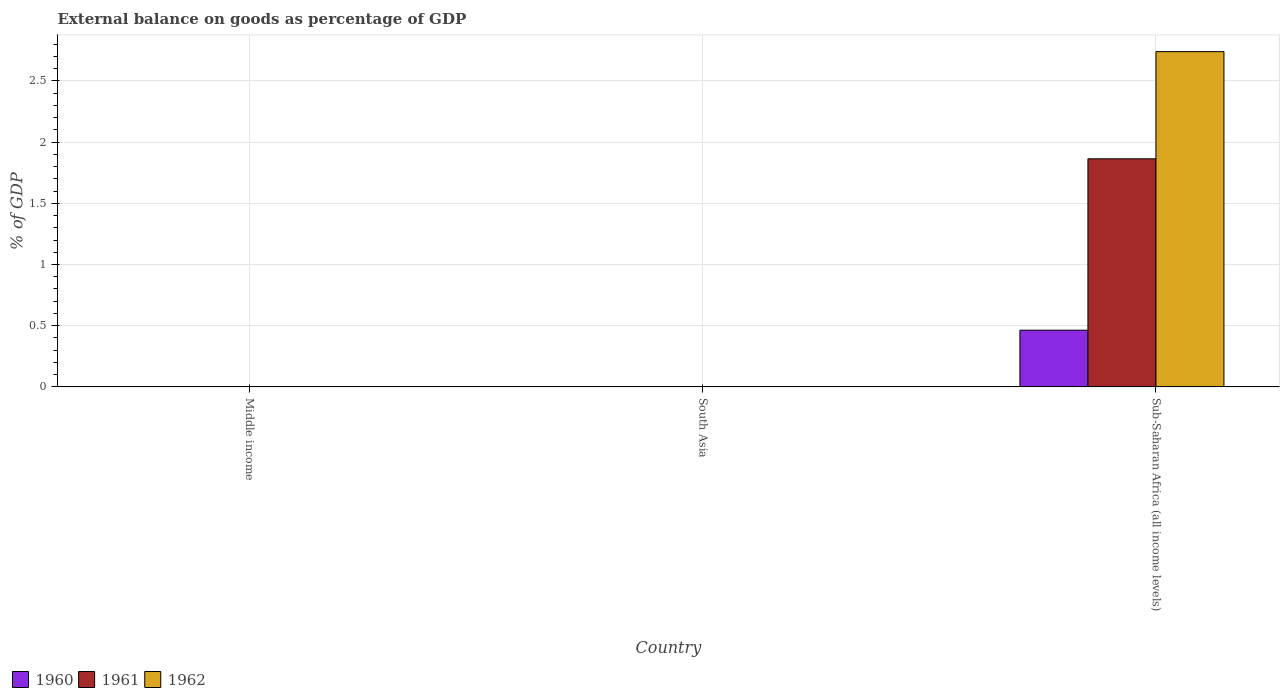How many different coloured bars are there?
Make the answer very short. 3. Are the number of bars per tick equal to the number of legend labels?
Make the answer very short. No. How many bars are there on the 1st tick from the left?
Your response must be concise. 0. How many bars are there on the 3rd tick from the right?
Make the answer very short. 0. In how many cases, is the number of bars for a given country not equal to the number of legend labels?
Keep it short and to the point. 2. What is the external balance on goods as percentage of GDP in 1962 in Sub-Saharan Africa (all income levels)?
Your answer should be very brief. 2.74. Across all countries, what is the maximum external balance on goods as percentage of GDP in 1961?
Offer a terse response. 1.86. Across all countries, what is the minimum external balance on goods as percentage of GDP in 1961?
Offer a very short reply. 0. In which country was the external balance on goods as percentage of GDP in 1961 maximum?
Keep it short and to the point. Sub-Saharan Africa (all income levels). What is the total external balance on goods as percentage of GDP in 1962 in the graph?
Give a very brief answer. 2.74. What is the difference between the external balance on goods as percentage of GDP in 1962 in Middle income and the external balance on goods as percentage of GDP in 1961 in Sub-Saharan Africa (all income levels)?
Ensure brevity in your answer.  -1.86. What is the average external balance on goods as percentage of GDP in 1962 per country?
Keep it short and to the point. 0.91. What is the difference between the external balance on goods as percentage of GDP of/in 1962 and external balance on goods as percentage of GDP of/in 1961 in Sub-Saharan Africa (all income levels)?
Your answer should be very brief. 0.88. In how many countries, is the external balance on goods as percentage of GDP in 1962 greater than 0.2 %?
Offer a terse response. 1. What is the difference between the highest and the lowest external balance on goods as percentage of GDP in 1961?
Offer a very short reply. 1.86. How many bars are there?
Your answer should be compact. 3. How many countries are there in the graph?
Keep it short and to the point. 3. Are the values on the major ticks of Y-axis written in scientific E-notation?
Your answer should be very brief. No. Does the graph contain any zero values?
Give a very brief answer. Yes. Does the graph contain grids?
Provide a succinct answer. Yes. How are the legend labels stacked?
Provide a short and direct response. Horizontal. What is the title of the graph?
Provide a short and direct response. External balance on goods as percentage of GDP. Does "2002" appear as one of the legend labels in the graph?
Your response must be concise. No. What is the label or title of the Y-axis?
Provide a succinct answer. % of GDP. What is the % of GDP of 1962 in Middle income?
Offer a terse response. 0. What is the % of GDP in 1961 in South Asia?
Provide a short and direct response. 0. What is the % of GDP of 1960 in Sub-Saharan Africa (all income levels)?
Give a very brief answer. 0.46. What is the % of GDP of 1961 in Sub-Saharan Africa (all income levels)?
Offer a very short reply. 1.86. What is the % of GDP in 1962 in Sub-Saharan Africa (all income levels)?
Offer a terse response. 2.74. Across all countries, what is the maximum % of GDP in 1960?
Offer a very short reply. 0.46. Across all countries, what is the maximum % of GDP of 1961?
Provide a succinct answer. 1.86. Across all countries, what is the maximum % of GDP of 1962?
Give a very brief answer. 2.74. Across all countries, what is the minimum % of GDP of 1960?
Keep it short and to the point. 0. Across all countries, what is the minimum % of GDP in 1962?
Make the answer very short. 0. What is the total % of GDP in 1960 in the graph?
Your answer should be very brief. 0.46. What is the total % of GDP of 1961 in the graph?
Keep it short and to the point. 1.86. What is the total % of GDP in 1962 in the graph?
Keep it short and to the point. 2.74. What is the average % of GDP of 1960 per country?
Ensure brevity in your answer.  0.15. What is the average % of GDP of 1961 per country?
Your answer should be compact. 0.62. What is the average % of GDP in 1962 per country?
Offer a very short reply. 0.91. What is the difference between the % of GDP in 1960 and % of GDP in 1961 in Sub-Saharan Africa (all income levels)?
Your response must be concise. -1.4. What is the difference between the % of GDP of 1960 and % of GDP of 1962 in Sub-Saharan Africa (all income levels)?
Your answer should be compact. -2.28. What is the difference between the % of GDP of 1961 and % of GDP of 1962 in Sub-Saharan Africa (all income levels)?
Offer a very short reply. -0.88. What is the difference between the highest and the lowest % of GDP of 1960?
Give a very brief answer. 0.46. What is the difference between the highest and the lowest % of GDP of 1961?
Your response must be concise. 1.86. What is the difference between the highest and the lowest % of GDP of 1962?
Offer a very short reply. 2.74. 